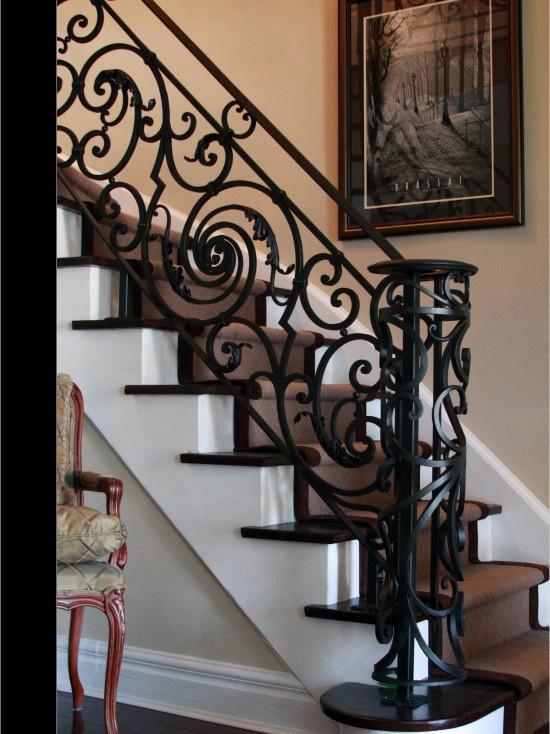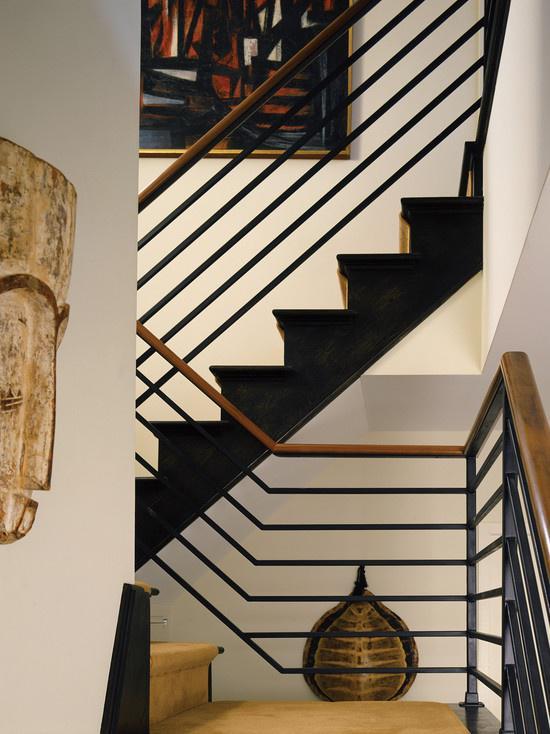The first image is the image on the left, the second image is the image on the right. Evaluate the accuracy of this statement regarding the images: "The left image shows a staircase with an ornate black wrought iron rail and a corner post featuring wrought iron curved around to form a cylinder shape.". Is it true? Answer yes or no. Yes. 